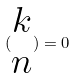Convert formula to latex. <formula><loc_0><loc_0><loc_500><loc_500>( \begin{matrix} k \\ n \end{matrix} ) = 0</formula> 